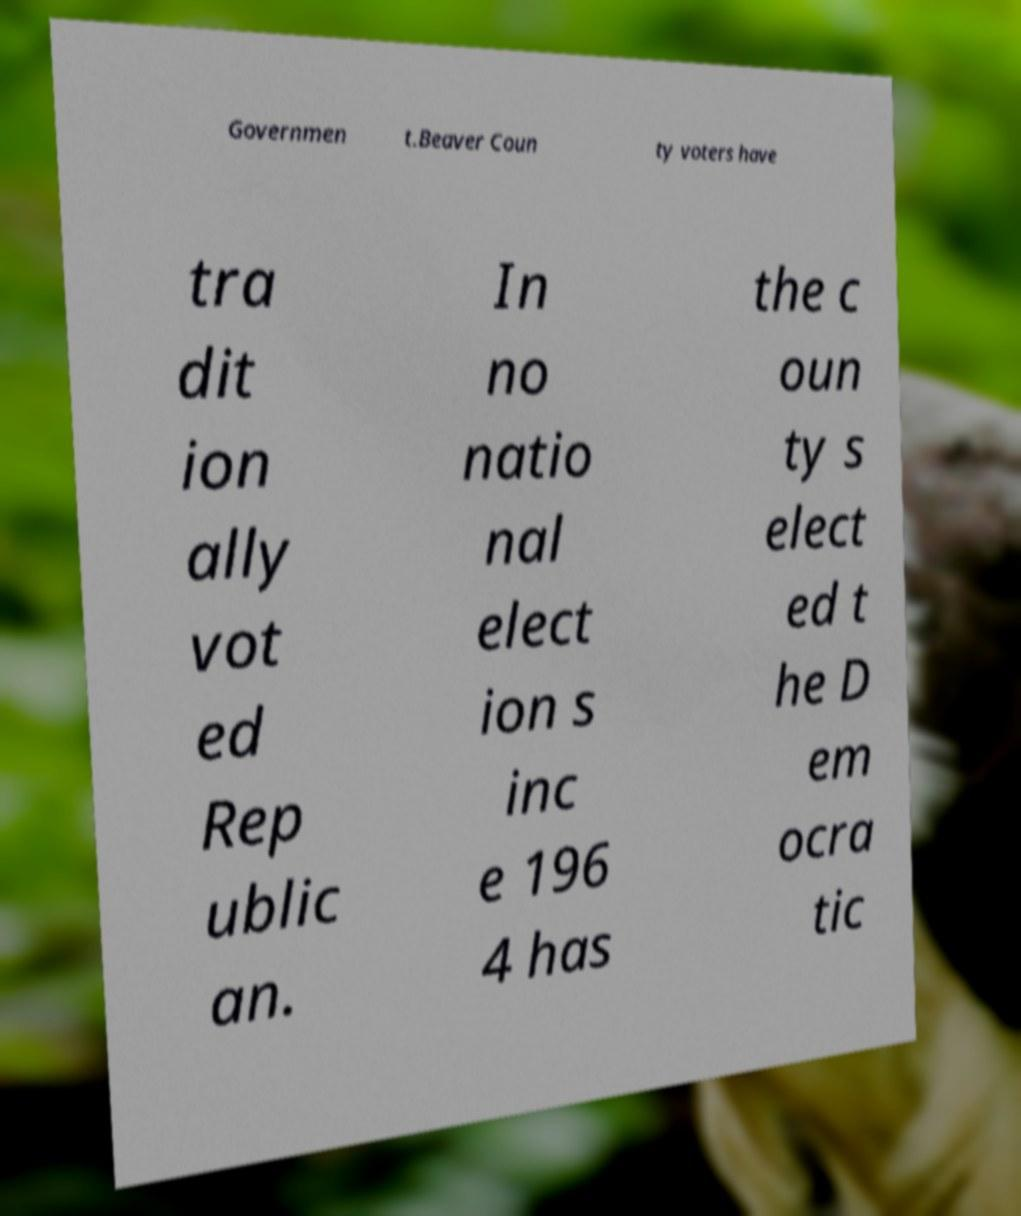Can you accurately transcribe the text from the provided image for me? Governmen t.Beaver Coun ty voters have tra dit ion ally vot ed Rep ublic an. In no natio nal elect ion s inc e 196 4 has the c oun ty s elect ed t he D em ocra tic 